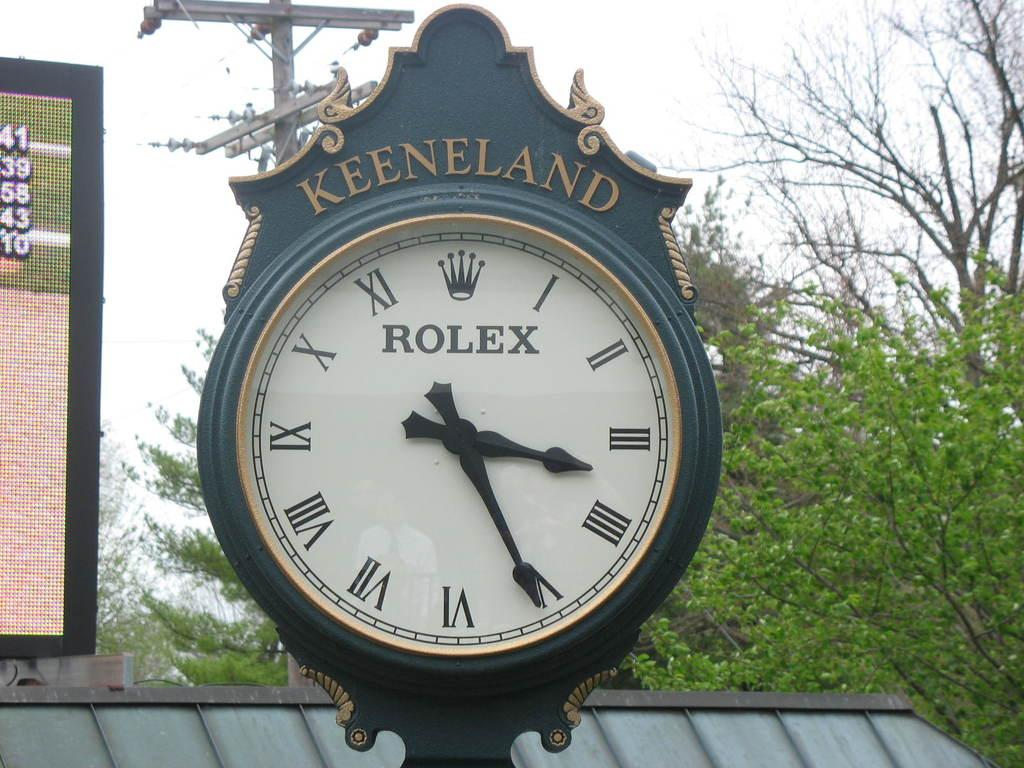<image>
Give a short and clear explanation of the subsequent image. A Keeneland Rolex clock shows the time of 3:26. 